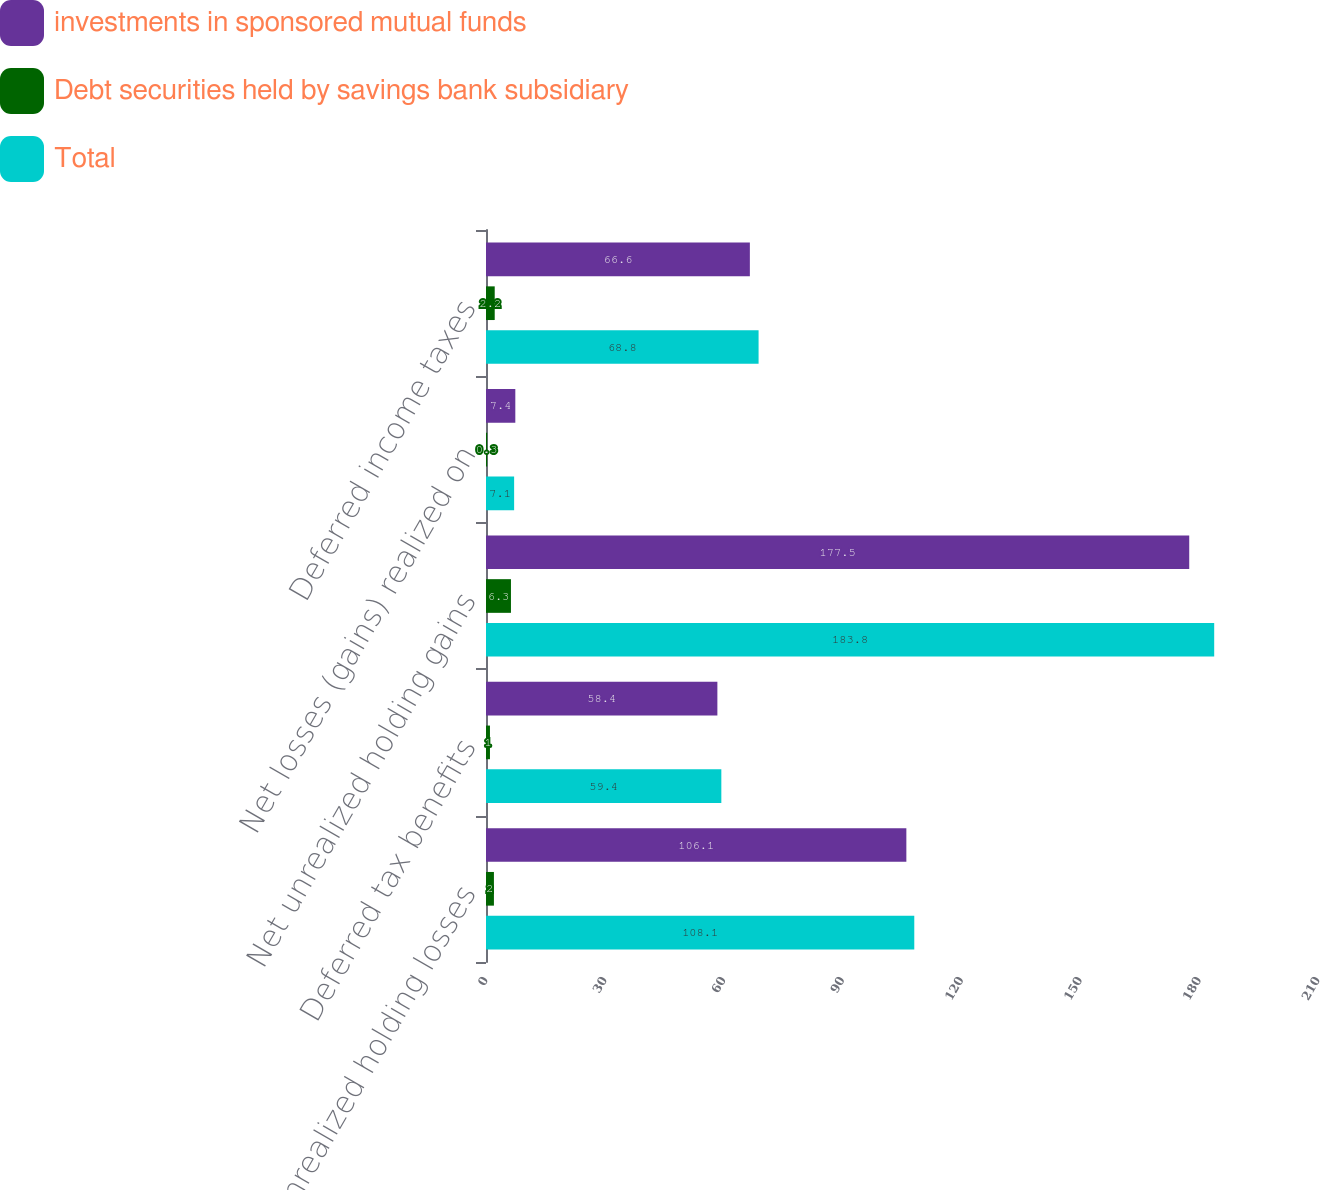Convert chart. <chart><loc_0><loc_0><loc_500><loc_500><stacked_bar_chart><ecel><fcel>Net unrealized holding losses<fcel>Deferred tax benefits<fcel>Net unrealized holding gains<fcel>Net losses (gains) realized on<fcel>Deferred income taxes<nl><fcel>investments in sponsored mutual funds<fcel>106.1<fcel>58.4<fcel>177.5<fcel>7.4<fcel>66.6<nl><fcel>Debt securities held by savings bank subsidiary<fcel>2<fcel>1<fcel>6.3<fcel>0.3<fcel>2.2<nl><fcel>Total<fcel>108.1<fcel>59.4<fcel>183.8<fcel>7.1<fcel>68.8<nl></chart> 